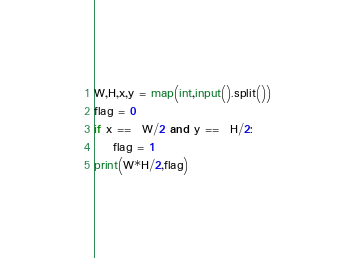Convert code to text. <code><loc_0><loc_0><loc_500><loc_500><_Python_>W,H,x,y = map(int,input().split())
flag = 0
if x ==  W/2 and y ==  H/2:
    flag = 1
print(W*H/2,flag)    </code> 